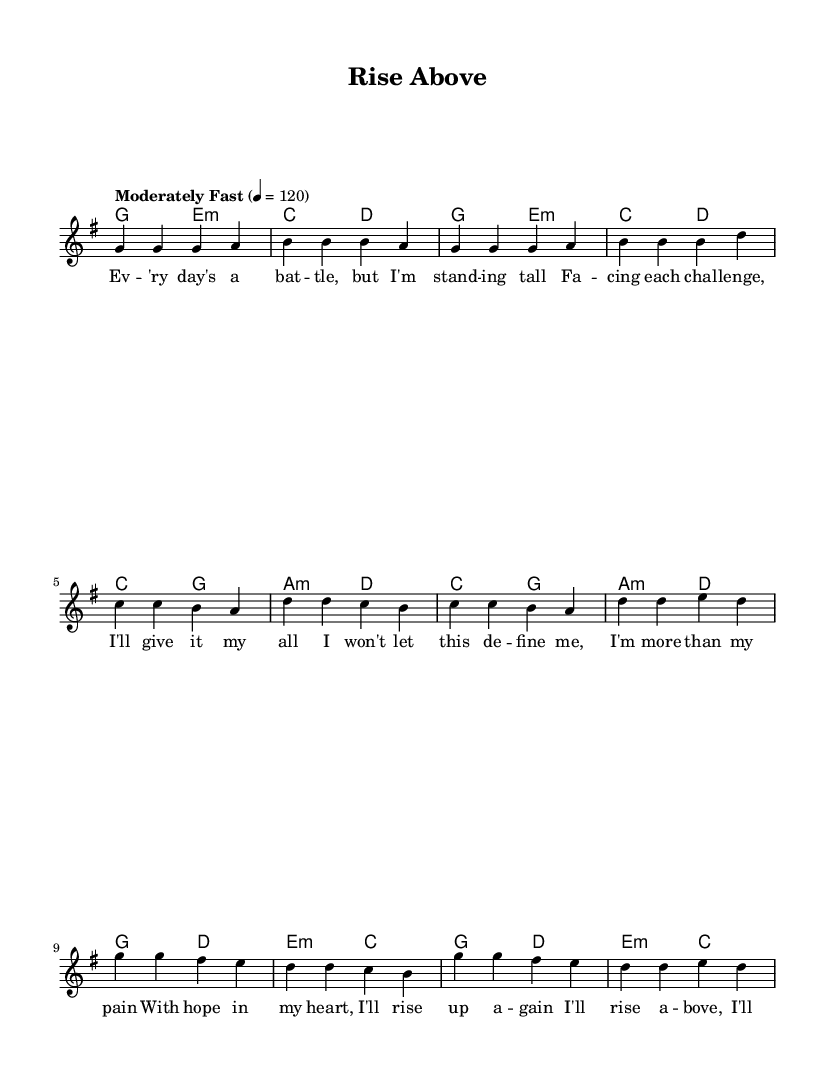What is the key signature of this music? The key signature is G major, which has one sharp (F#). This can be identified by checking the key indicated at the beginning of the music sheet.
Answer: G major What is the time signature of this music? The time signature is 4/4, as shown at the beginning of the score. This indicates that there are four beats per measure and the quarter note gets one beat.
Answer: 4/4 What is the tempo marking of the piece? The tempo marking is "Moderately Fast," indicated alongside the tempo notation (4 = 120), which specifies the speed of the piece in beats per minute.
Answer: Moderately Fast How many measures are in the verse? The verse consists of 8 measures, which can be counted by ensuring each measure is separated by a vertical bar, totaling to 8 segments in the melody section provided for the verse.
Answer: 8 Which chords are used in the pre-chorus? The pre-chorus includes the chords C, G, A minor, and D. These chords can be found in the harmonies section, where they are represented for the pre-chorus part specifically.
Answer: C, G, A minor, D What is the first lyric of the chorus? The first lyric of the chorus is "I'll rise above." This can be confirmed by looking at the lyric section associated with the melody during the chorus.
Answer: I'll rise above How many unique notes are in the melody? There are 7 unique notes in the melody: G, A, B, C, D, E, F sharp. By analyzing the melody line and identifying each distinct note written, you can count these uniquely presented pitches.
Answer: 7 